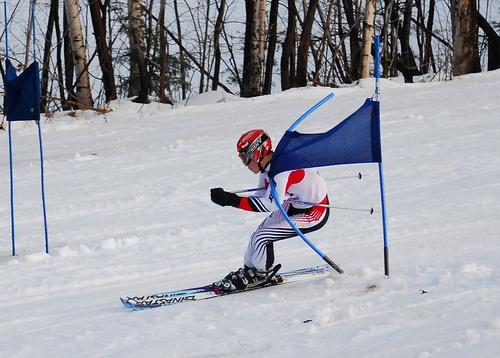Which direction is the skier facing?
Give a very brief answer. Downhill. Is the skier going to fall?
Give a very brief answer. No. Is this a competition?
Write a very short answer. Yes. 